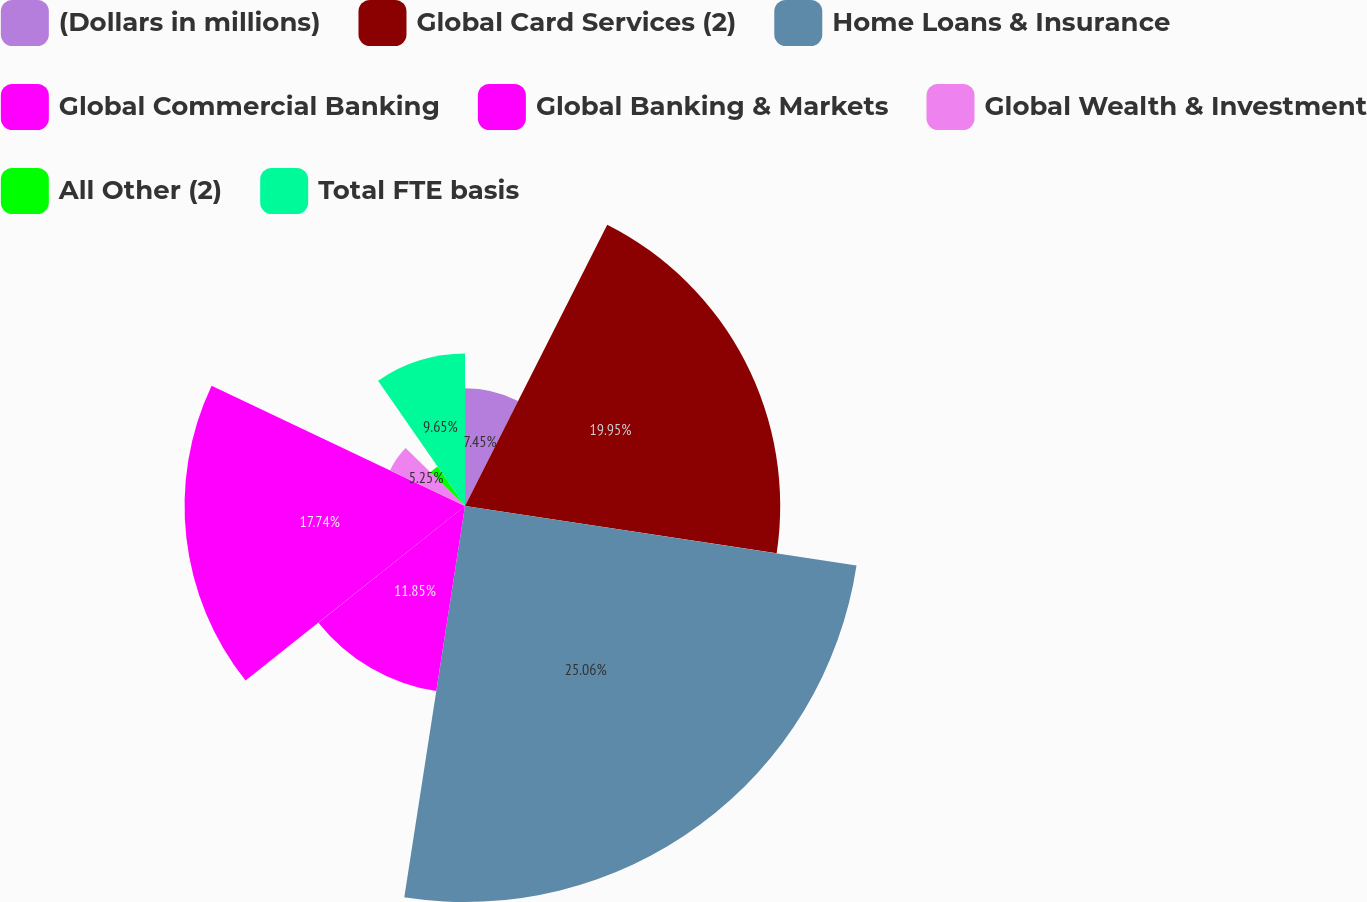Convert chart. <chart><loc_0><loc_0><loc_500><loc_500><pie_chart><fcel>(Dollars in millions)<fcel>Global Card Services (2)<fcel>Home Loans & Insurance<fcel>Global Commercial Banking<fcel>Global Banking & Markets<fcel>Global Wealth & Investment<fcel>All Other (2)<fcel>Total FTE basis<nl><fcel>7.45%<fcel>19.94%<fcel>25.05%<fcel>11.85%<fcel>17.74%<fcel>5.25%<fcel>3.05%<fcel>9.65%<nl></chart> 